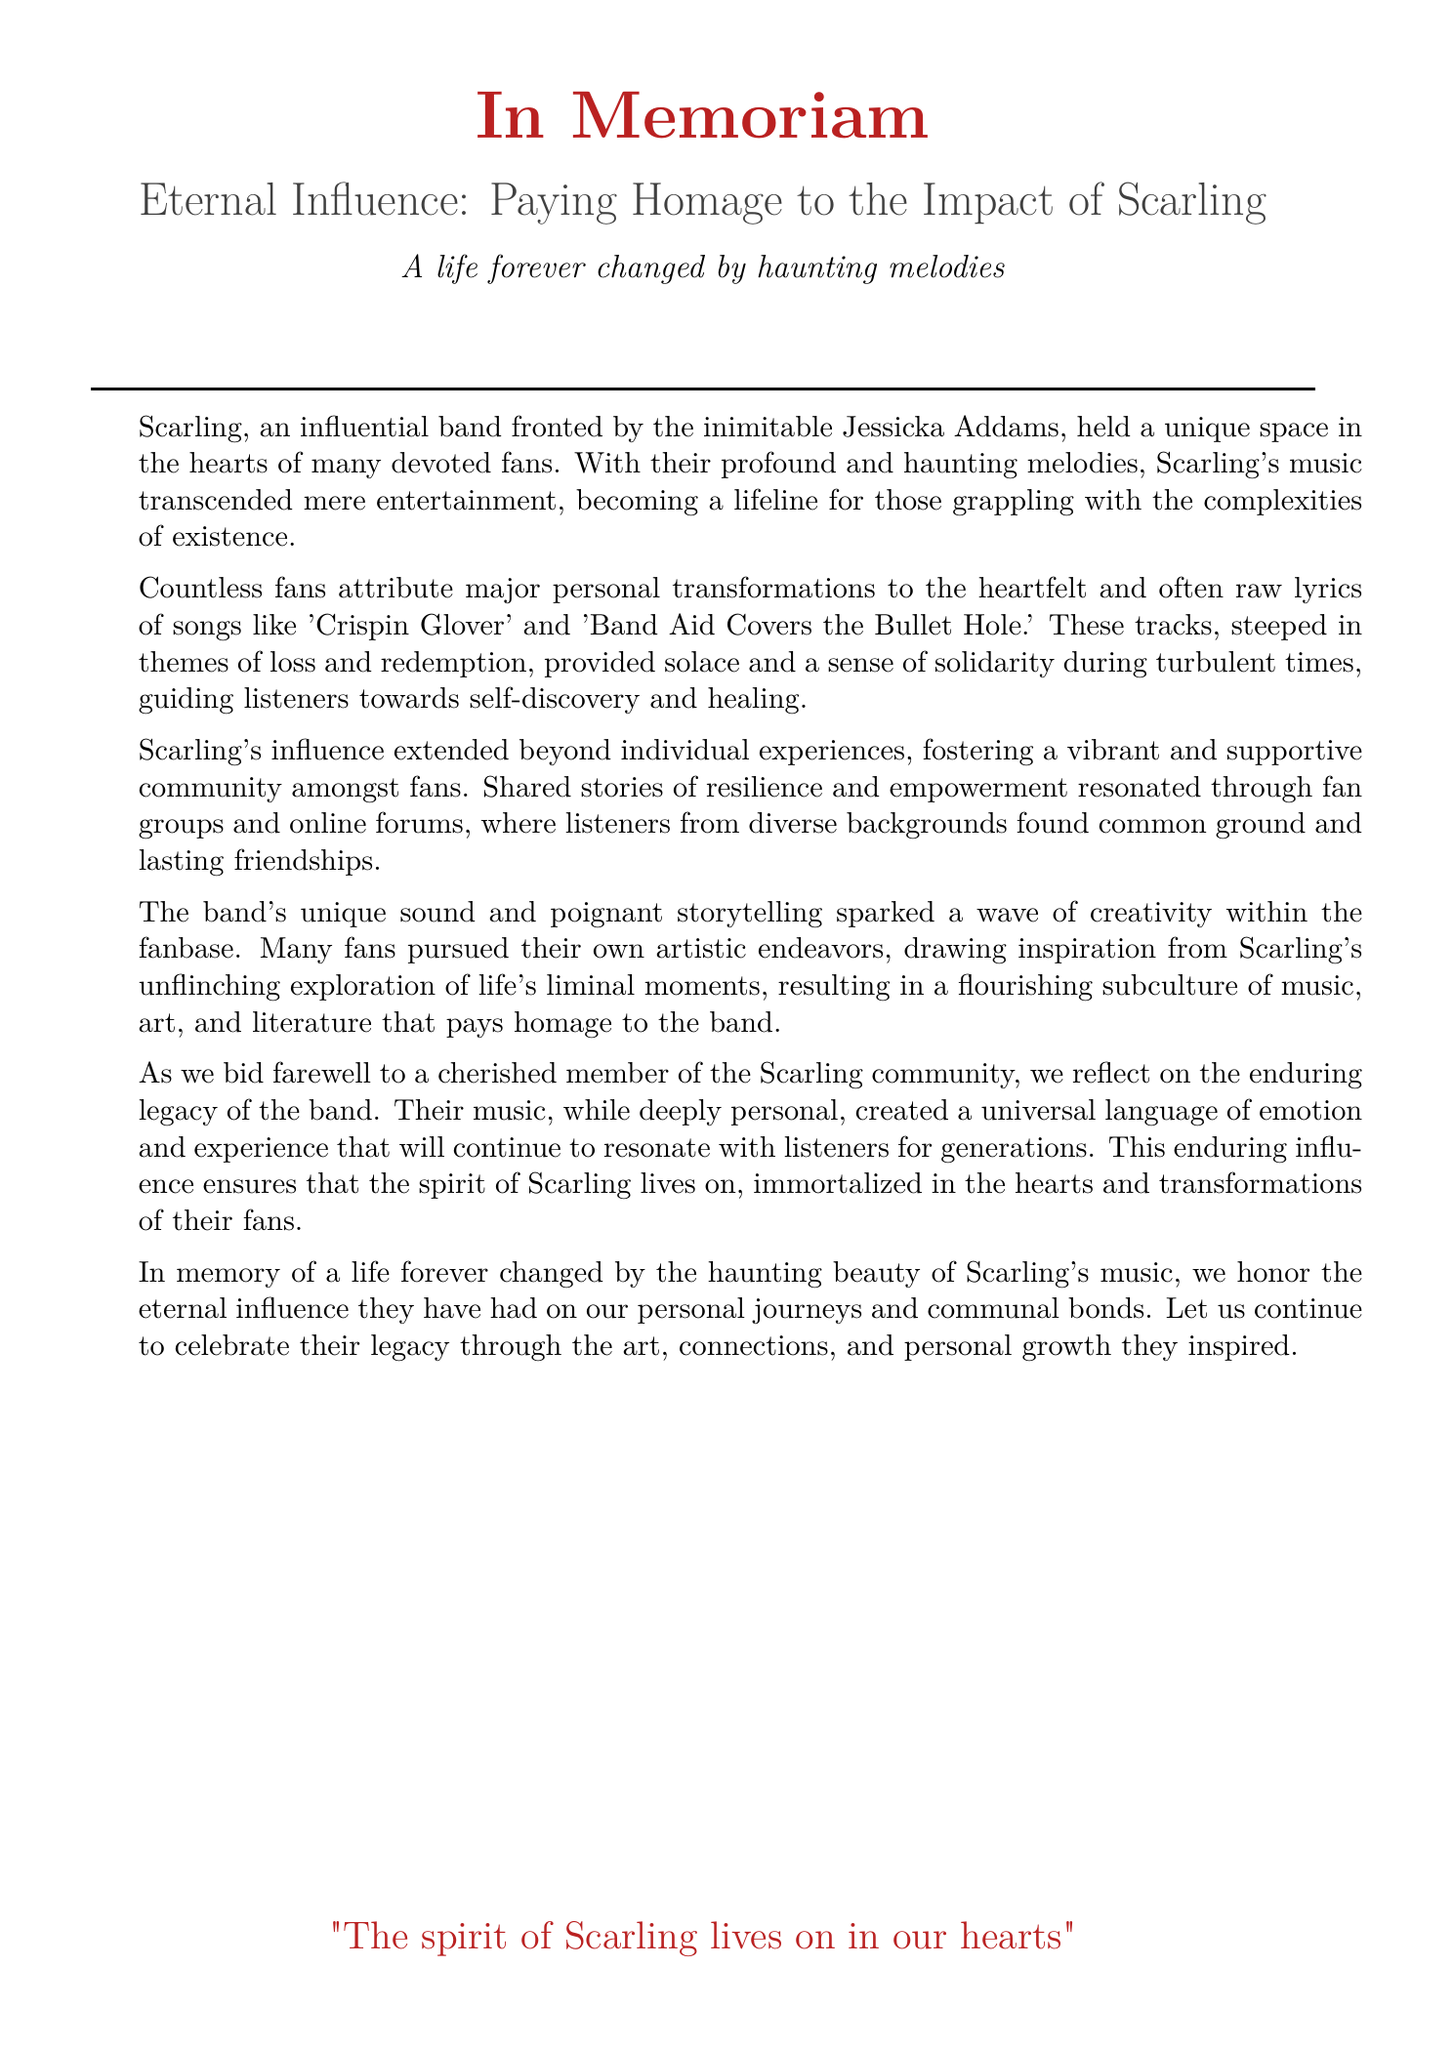what is the name of the band mentioned? The band mentioned in the document is Scarling.
Answer: Scarling who is the frontperson of Scarling? Jessicka Addams is identified as the frontperson of Scarling in the document.
Answer: Jessicka Addams which song is mentioned alongside 'Crispin Glover'? The song mentioned alongside 'Crispin Glover' is 'Band Aid Covers the Bullet Hole.'
Answer: Band Aid Covers the Bullet Hole what themes are prevalent in Scarling's songs according to the document? The prevalent themes in Scarling's songs are loss and redemption.
Answer: loss and redemption how did Scarling's music impact fans according to the document? Scarling's music impacted fans by providing solace and a sense of solidarity during turbulent times.
Answer: solace and solidarity what type of community did Scarling's music foster among fans? Scarling's music fostered a vibrant and supportive community among fans.
Answer: supportive community what medium did fans pursue as a result of Scarling's influence? Fans pursued artistic endeavors, including music, art, and literature, as a result of Scarling's influence.
Answer: artistic endeavors how long will Scarling's influence resonate with listeners? The document states Scarling's influence will resonate with listeners for generations.
Answer: for generations what is the overarching sentiment expressed in the closing statement? The closing statement expresses a desire to celebrate Scarling's legacy.
Answer: celebrate their legacy 